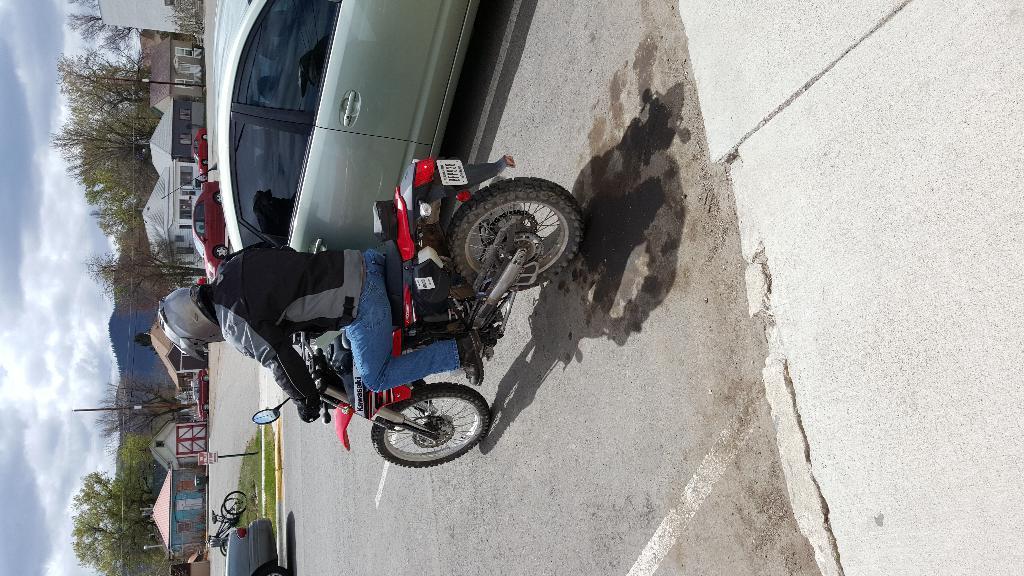In one or two sentences, can you explain what this image depicts? In this image there is a man sitting on the bike which is on the road. Beside the bike there is a car. In the background there are houses one beside the other. In between them there are trees. There are few cycles parked on the ground, beside the road. There is a board on the footpath. At the top there is the sky. 